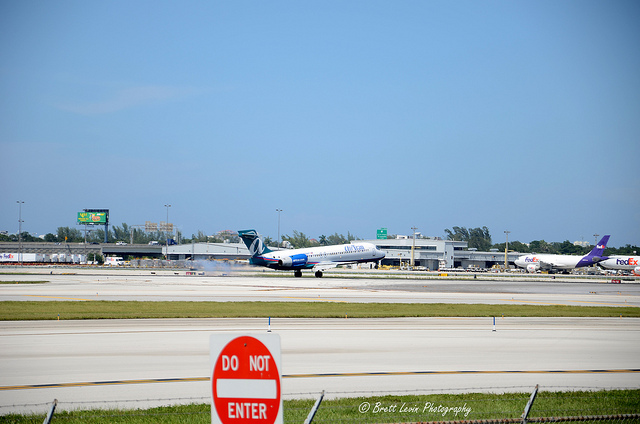Please extract the text content from this image. DO NOT ENTER Brett Photography Fedex Fedex 